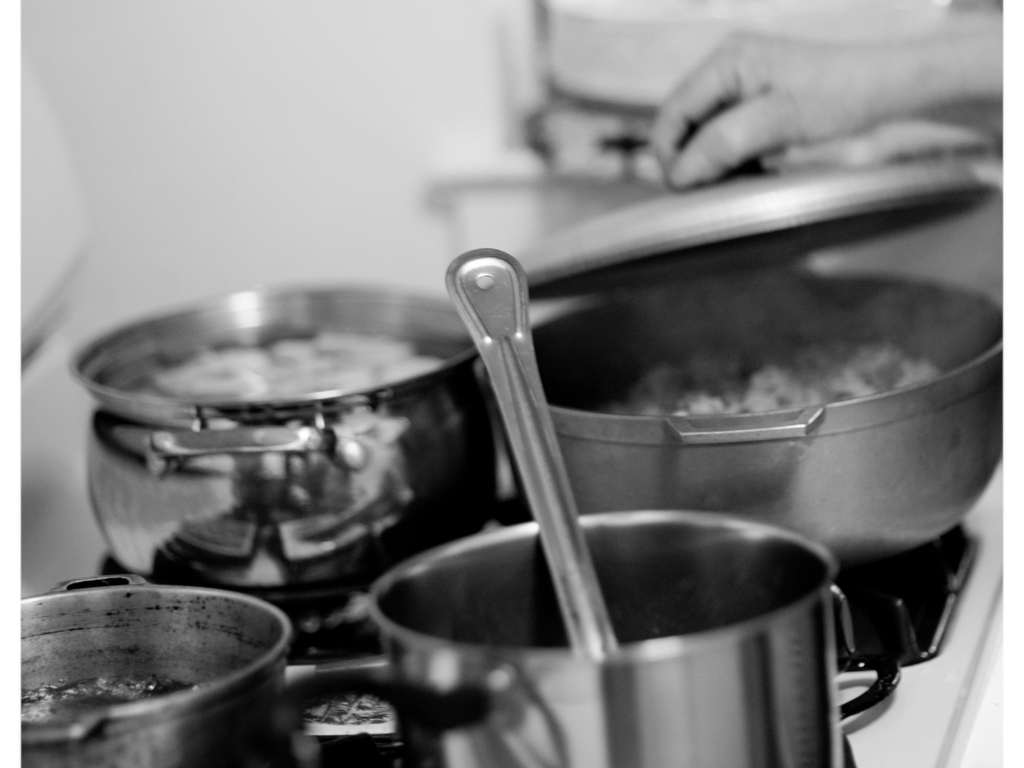What does the steam in the photo suggest about the environment in which it was taken? The presence of steam suggests a warm, active kitchen environment, most likely bustling with the preparation of food. The steam indicates that cooking is happening at multiple stations, emphasizing a sense of homeliness and nourishment. It also adds a transient quality to the scene, capturing a moment in time during the cooking process. 